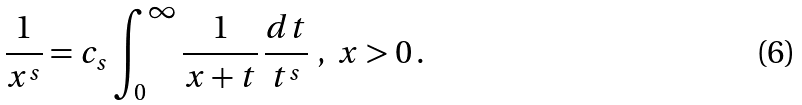Convert formula to latex. <formula><loc_0><loc_0><loc_500><loc_500>\frac { 1 } { x ^ { s } } = c _ { s } \int _ { 0 } ^ { \infty } \frac { 1 } { x + t } \, \frac { d t } { t ^ { s } } \ , \ x > 0 \, .</formula> 